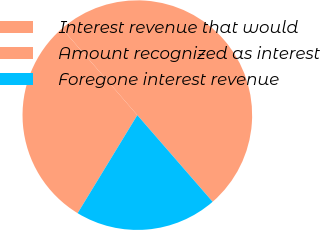<chart> <loc_0><loc_0><loc_500><loc_500><pie_chart><fcel>Interest revenue that would<fcel>Amount recognized as interest<fcel>Foregone interest revenue<nl><fcel>50.0%<fcel>29.91%<fcel>20.09%<nl></chart> 